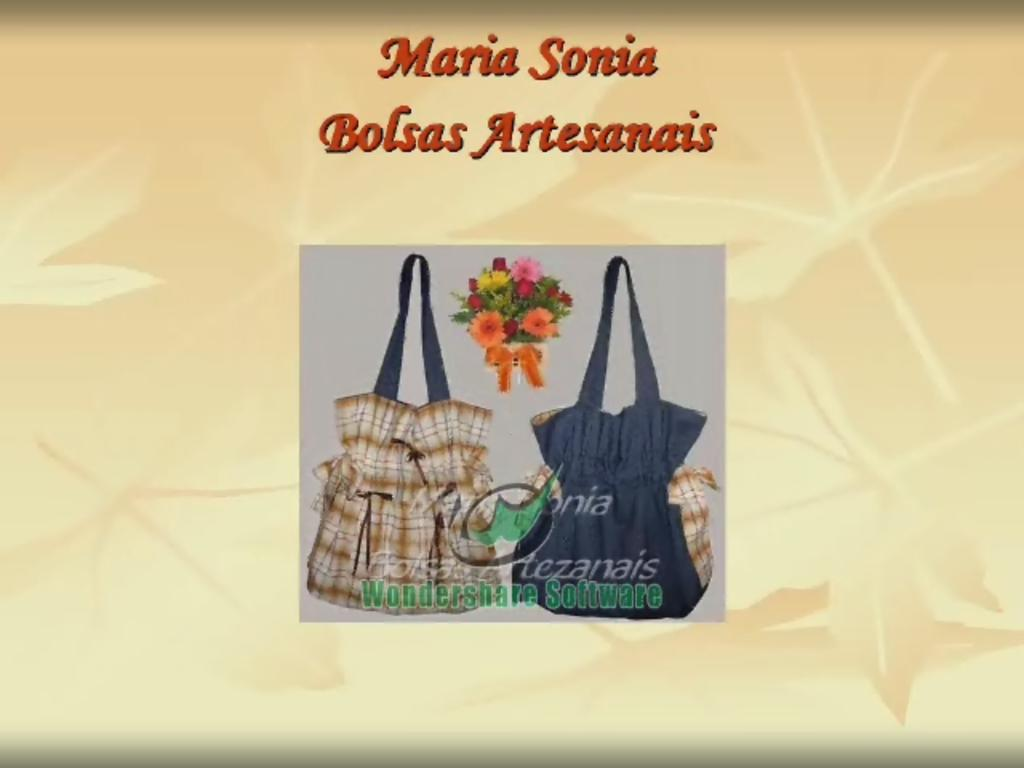What is featured on the poster in the image? There is a poster with text in the image. What type of objects can be seen in the image with bags? There is an image with bags in the image. What type of decorative item is present in the image? There is a flower bouquet in the image. What type of content is present in the image besides the poster? There is text present in the image. What type of army is depicted in the image? There is no army present in the image. What type of partner is featured in the image? There is no partner present in the image. 